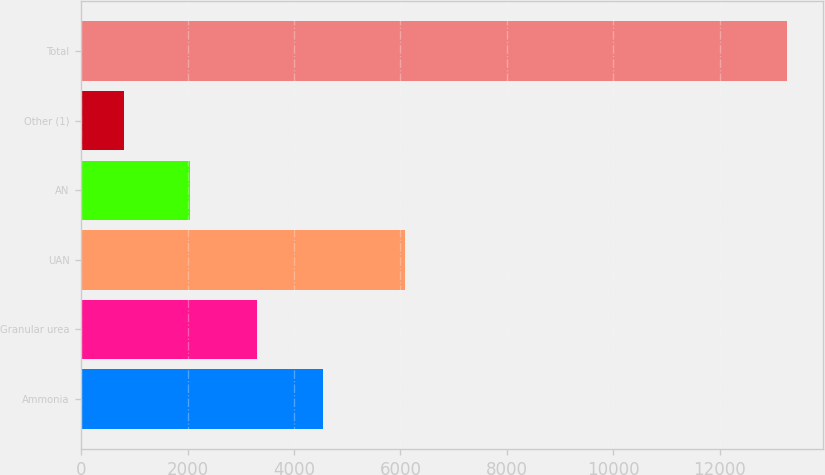Convert chart to OTSL. <chart><loc_0><loc_0><loc_500><loc_500><bar_chart><fcel>Ammonia<fcel>Granular urea<fcel>UAN<fcel>AN<fcel>Other (1)<fcel>Total<nl><fcel>4541.4<fcel>3293.6<fcel>6092<fcel>2045.8<fcel>798<fcel>13276<nl></chart> 